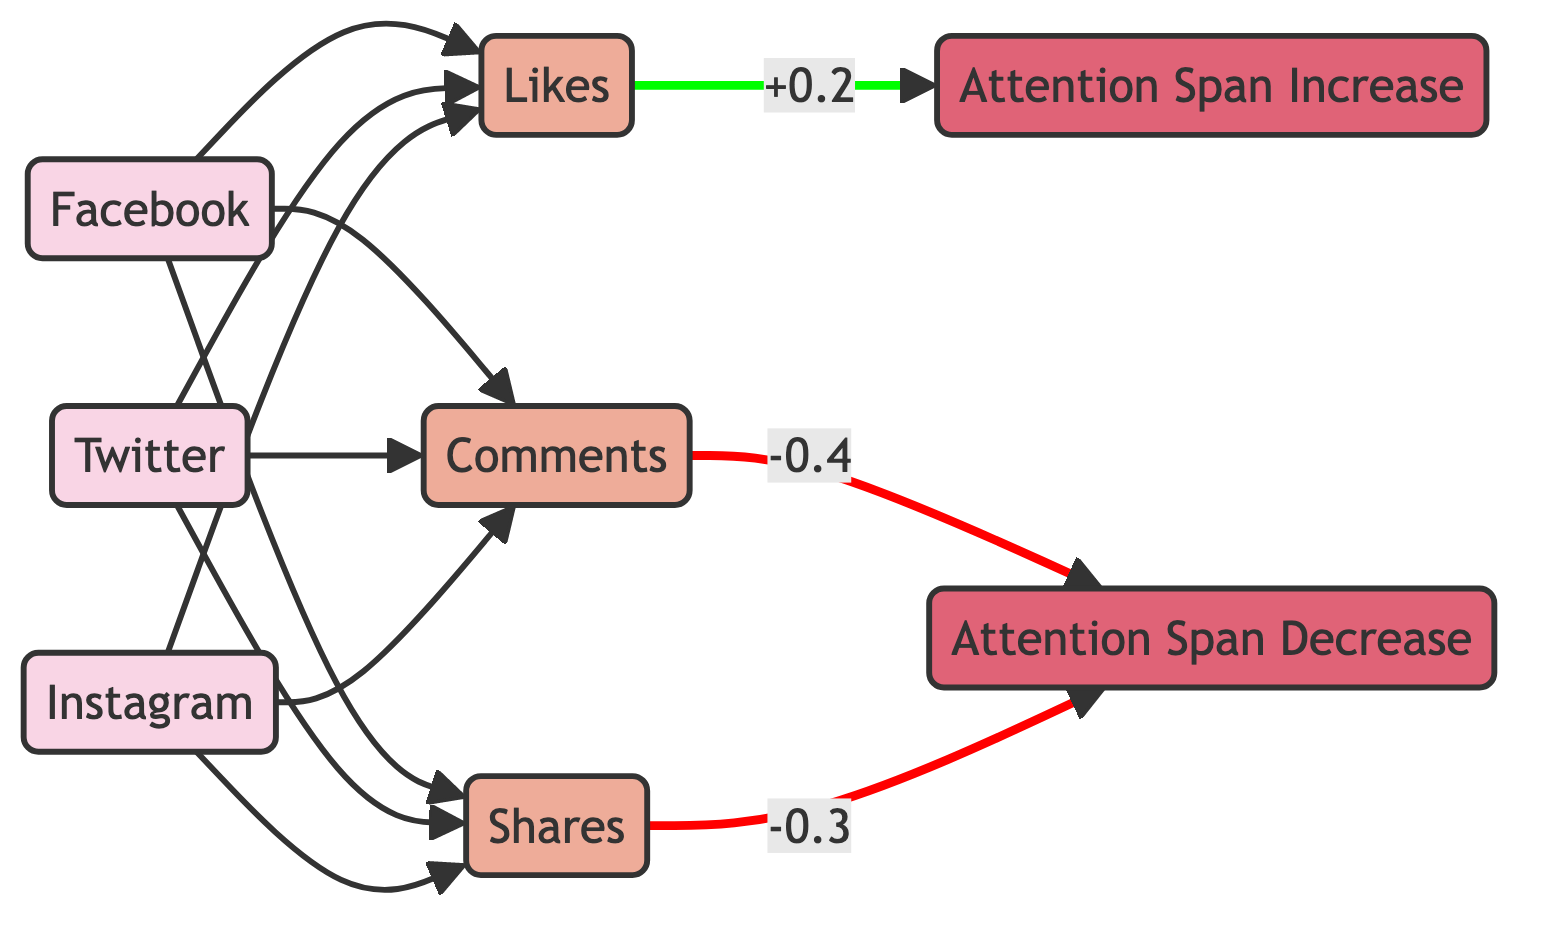What are the three social media platforms represented in the diagram? The diagram explicitly lists three nodes with the label "Social Media Platform," which are Facebook, Twitter, and Instagram.
Answer: Facebook, Twitter, Instagram How many interaction types are depicted in the diagram? There are three nodes labeled as "Interaction Type," which are Likes, Comments, and Shares. Thus, the total count is three.
Answer: 3 Which interaction type is associated with an increase in attention span? The diagram shows an edge leading from Likes to Attention Span Increase, indicating that Likes are correlated with an increase in attention span.
Answer: Likes What is the correlation weight between Likes and Attention Span Increase? The edge from Likes to Attention Span Increase has a label showing the correlation weight of 0.2.
Answer: 0.2 What type of relationship exists between Comments and Attention Span Decrease? The connection indicates that Comments are correlated with Attention Span Decrease, as noted by the labeled edge in the diagram.
Answer: correlated with Which social media platform does not lead to Attention Span Increase? The diagram links Likes to Attention Span Increase, but Comments and Shares lead to Attention Span Decrease. Since Comments do not enhance attention span, they belong to this criterion.
Answer: Comments How many edges are connected to Instagram? Each platform (including Instagram) supports Likes, Comments, and Shares, resulting in three distinct edges connected to the Instagram node.
Answer: 3 Which interaction type shows the strongest negative correlation with attention span? Among the edges leading to Attention Span Decrease, Comments show the strongest negative correlation with a weight of -0.4, making it the interaction type with the most significant negative impact.
Answer: Comments What is the total number of nodes in this diagram? By adding the number of nodes representing social media platforms, interaction types, and attention span variations, we find a total of eight nodes depicted in the diagram.
Answer: 8 